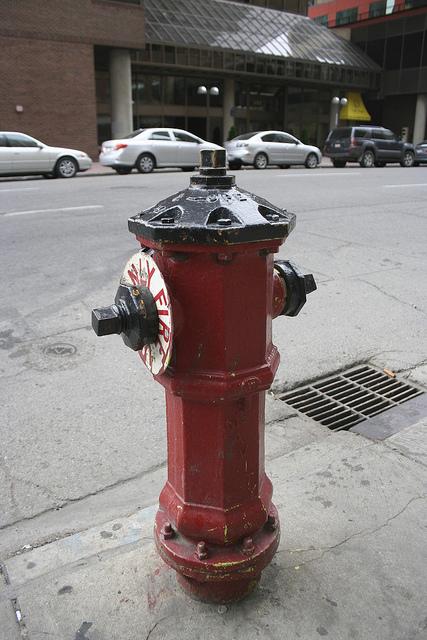How many cars are visible?
Write a very short answer. 4. IS the fire hydrant yellow?
Quick response, please. No. How many black parts are on the fire hydrant?
Concise answer only. 3. 